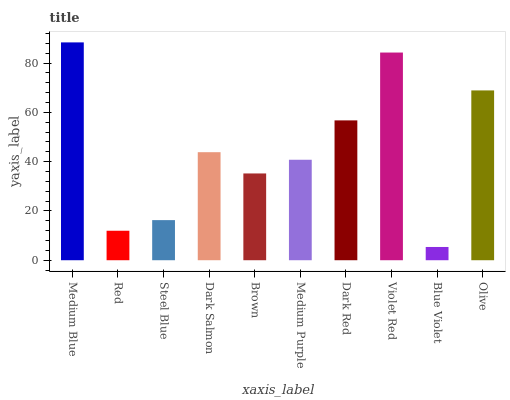Is Blue Violet the minimum?
Answer yes or no. Yes. Is Medium Blue the maximum?
Answer yes or no. Yes. Is Red the minimum?
Answer yes or no. No. Is Red the maximum?
Answer yes or no. No. Is Medium Blue greater than Red?
Answer yes or no. Yes. Is Red less than Medium Blue?
Answer yes or no. Yes. Is Red greater than Medium Blue?
Answer yes or no. No. Is Medium Blue less than Red?
Answer yes or no. No. Is Dark Salmon the high median?
Answer yes or no. Yes. Is Medium Purple the low median?
Answer yes or no. Yes. Is Dark Red the high median?
Answer yes or no. No. Is Steel Blue the low median?
Answer yes or no. No. 